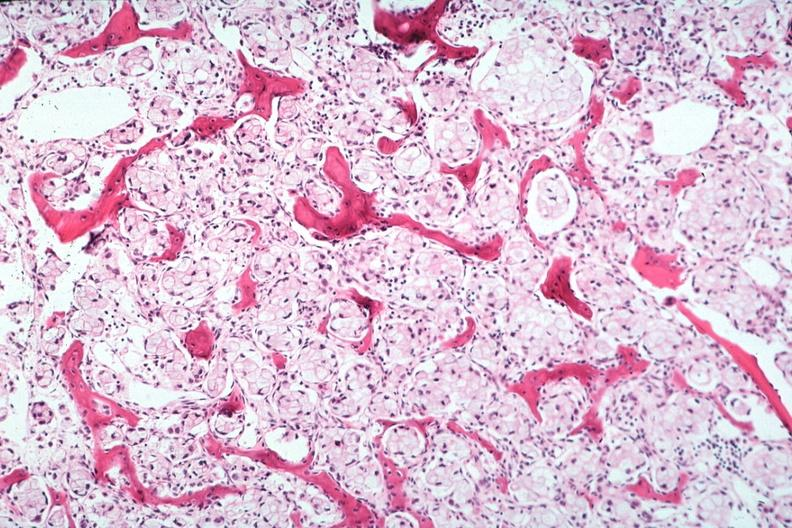does eosinophilic adenoma show stomach primary?
Answer the question using a single word or phrase. No 